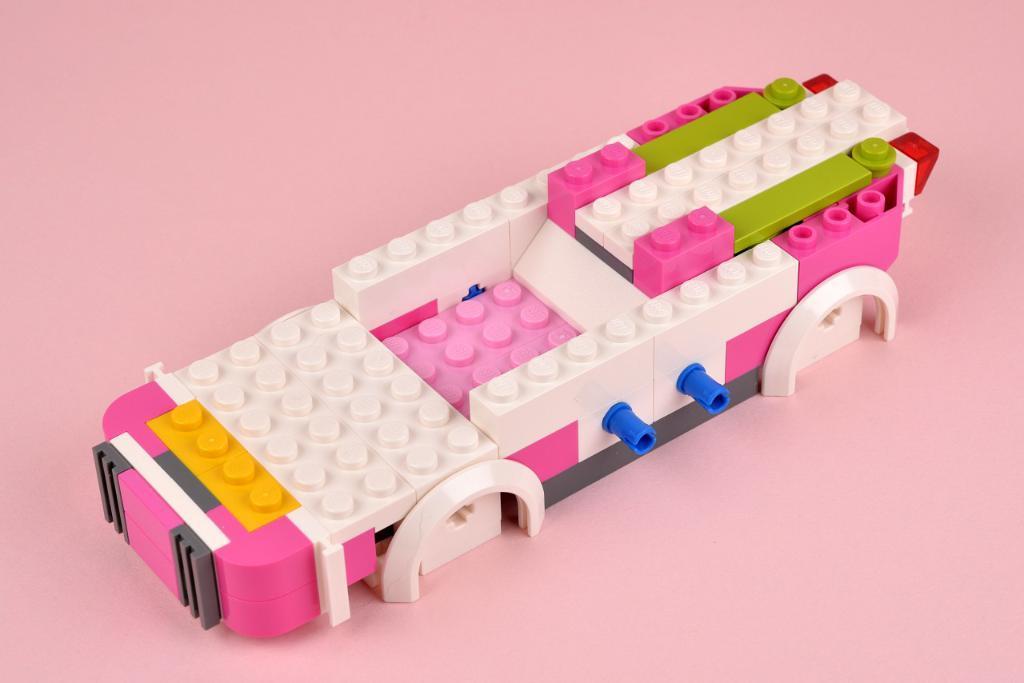Describe this image in one or two sentences. In this image there are Lego building blocks. 